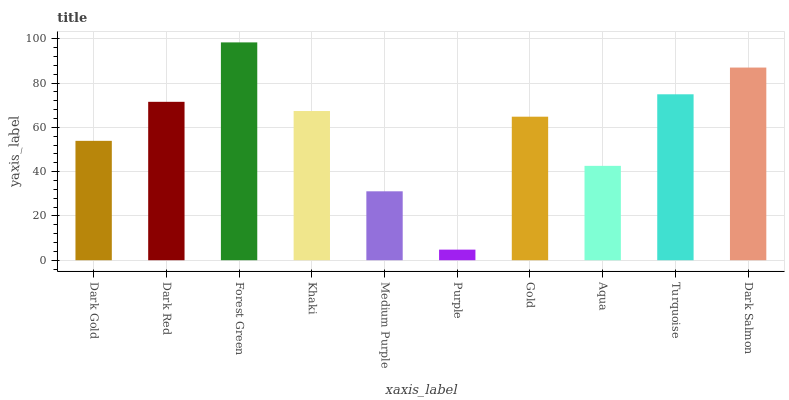Is Purple the minimum?
Answer yes or no. Yes. Is Forest Green the maximum?
Answer yes or no. Yes. Is Dark Red the minimum?
Answer yes or no. No. Is Dark Red the maximum?
Answer yes or no. No. Is Dark Red greater than Dark Gold?
Answer yes or no. Yes. Is Dark Gold less than Dark Red?
Answer yes or no. Yes. Is Dark Gold greater than Dark Red?
Answer yes or no. No. Is Dark Red less than Dark Gold?
Answer yes or no. No. Is Khaki the high median?
Answer yes or no. Yes. Is Gold the low median?
Answer yes or no. Yes. Is Dark Red the high median?
Answer yes or no. No. Is Dark Salmon the low median?
Answer yes or no. No. 